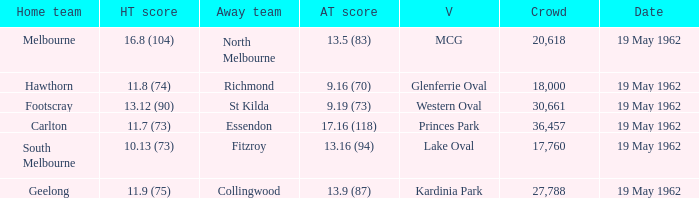Parse the table in full. {'header': ['Home team', 'HT score', 'Away team', 'AT score', 'V', 'Crowd', 'Date'], 'rows': [['Melbourne', '16.8 (104)', 'North Melbourne', '13.5 (83)', 'MCG', '20,618', '19 May 1962'], ['Hawthorn', '11.8 (74)', 'Richmond', '9.16 (70)', 'Glenferrie Oval', '18,000', '19 May 1962'], ['Footscray', '13.12 (90)', 'St Kilda', '9.19 (73)', 'Western Oval', '30,661', '19 May 1962'], ['Carlton', '11.7 (73)', 'Essendon', '17.16 (118)', 'Princes Park', '36,457', '19 May 1962'], ['South Melbourne', '10.13 (73)', 'Fitzroy', '13.16 (94)', 'Lake Oval', '17,760', '19 May 1962'], ['Geelong', '11.9 (75)', 'Collingwood', '13.9 (87)', 'Kardinia Park', '27,788', '19 May 1962']]} What is the away team's score when the home team scores 16.8 (104)? 13.5 (83). 